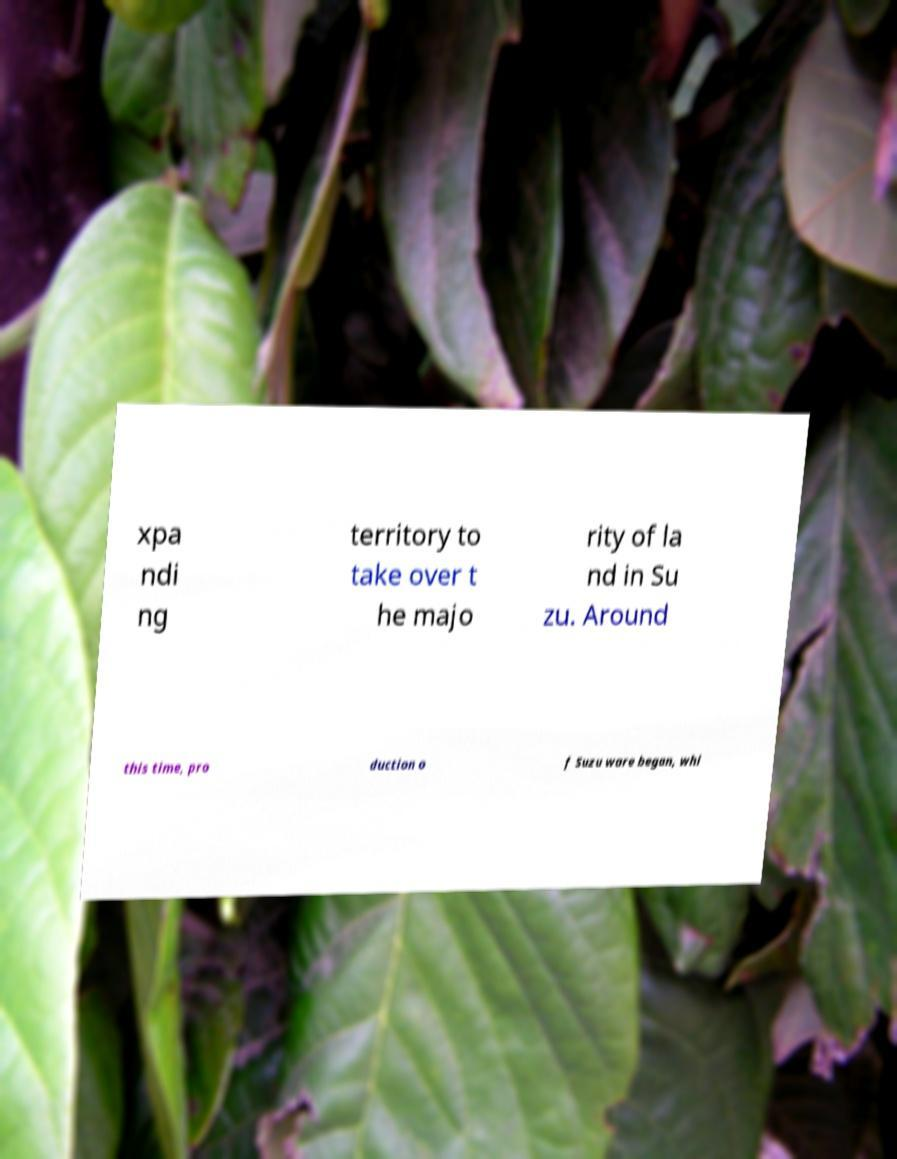Could you extract and type out the text from this image? xpa ndi ng territory to take over t he majo rity of la nd in Su zu. Around this time, pro duction o f Suzu ware began, whi 